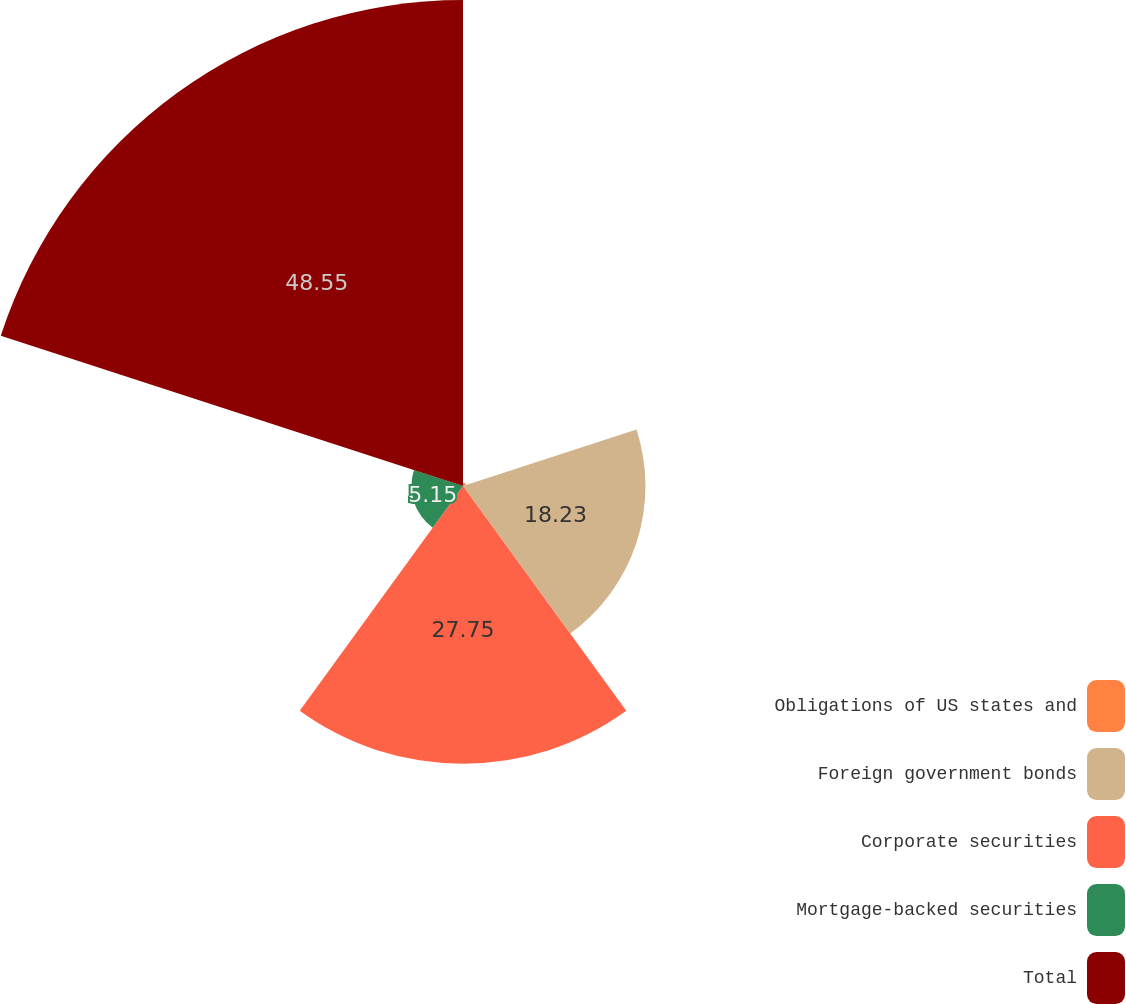Convert chart. <chart><loc_0><loc_0><loc_500><loc_500><pie_chart><fcel>Obligations of US states and<fcel>Foreign government bonds<fcel>Corporate securities<fcel>Mortgage-backed securities<fcel>Total<nl><fcel>0.32%<fcel>18.23%<fcel>27.75%<fcel>5.15%<fcel>48.56%<nl></chart> 